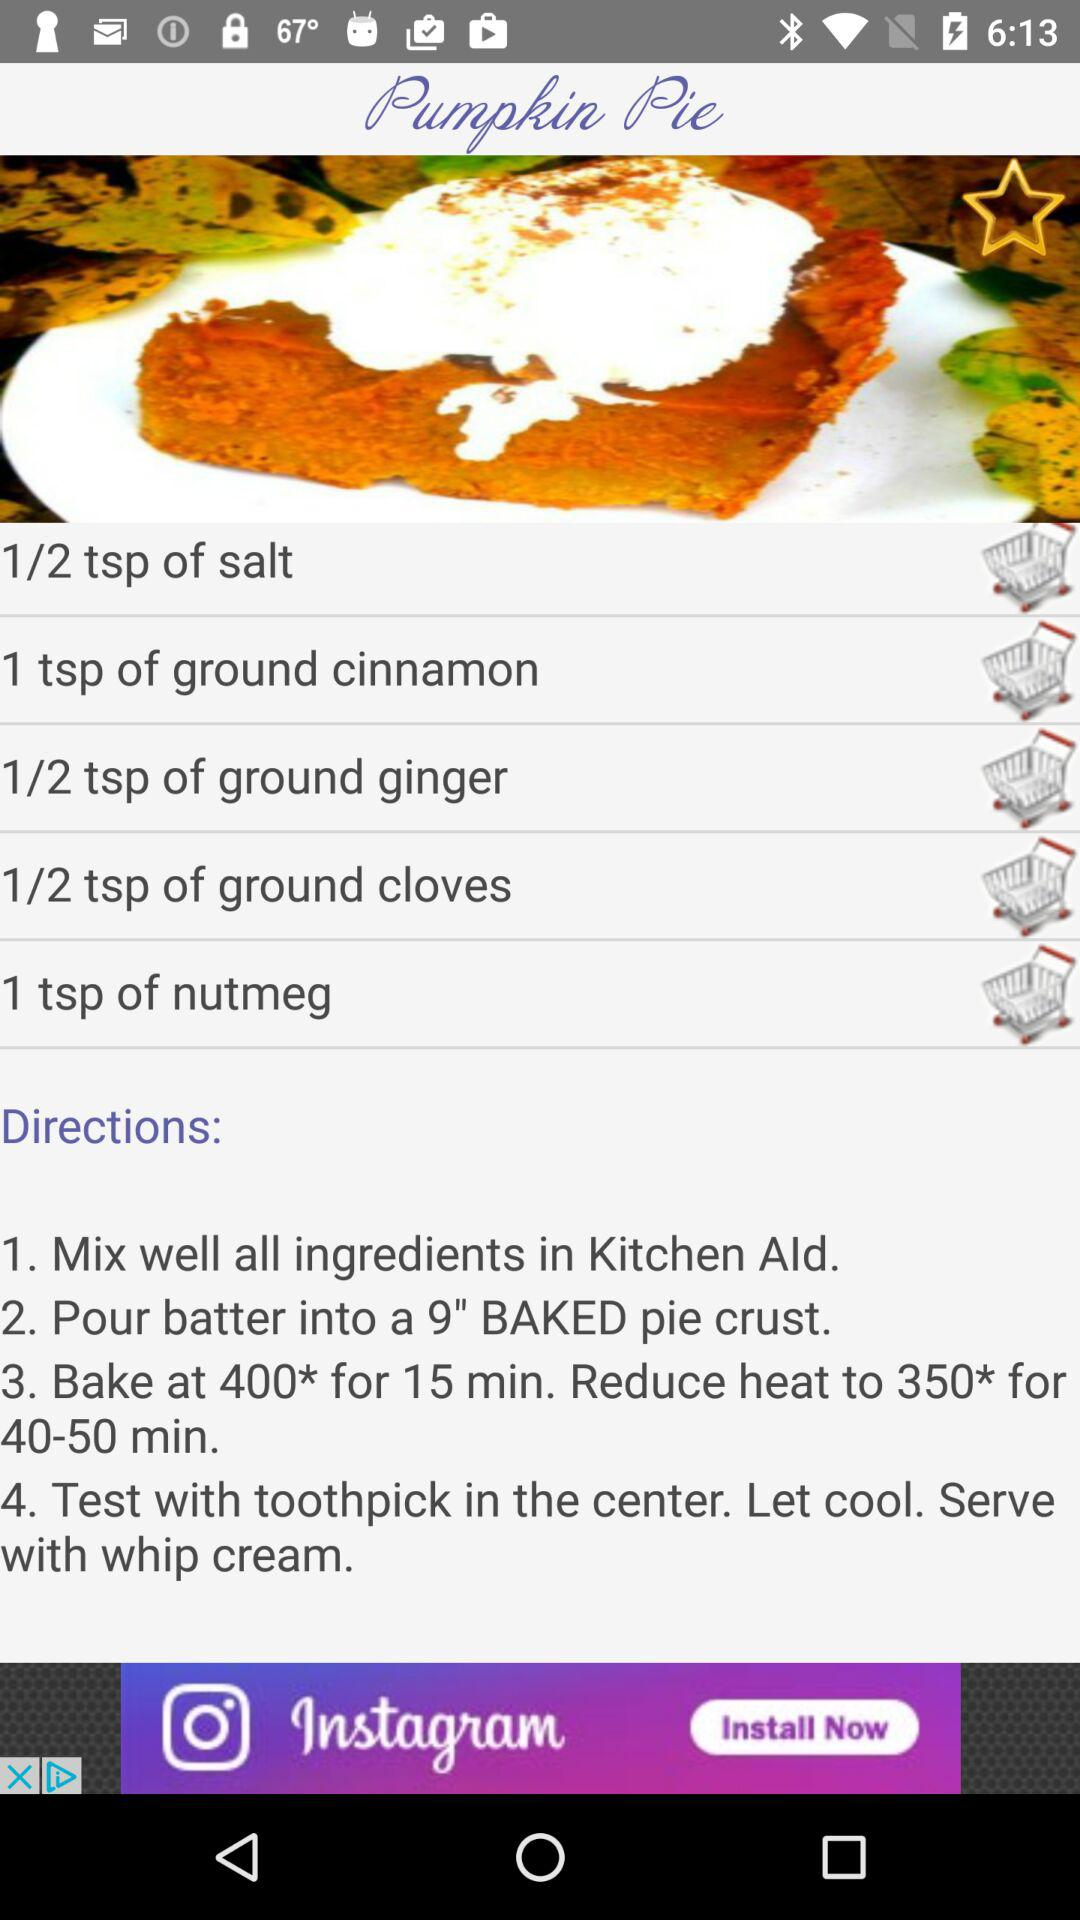How many steps are in the directions?
Answer the question using a single word or phrase. 4 